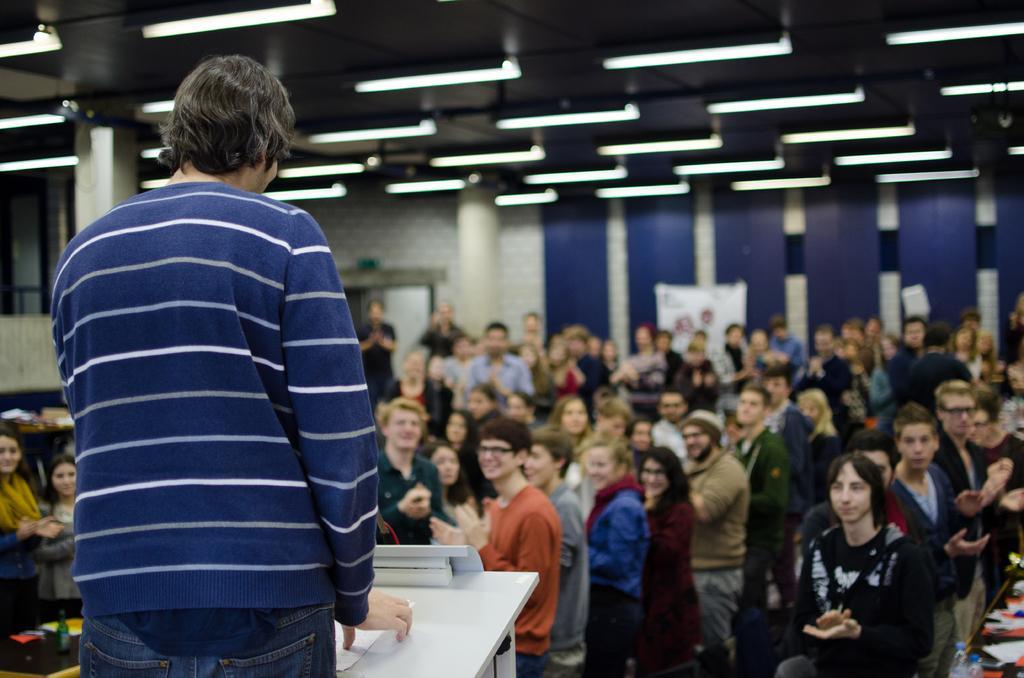Could you give a brief overview of what you see in this image? In this picture I can see a person standing in front of the table and holding paper, in front so many people are clapping their hands and also I can see some lights to the roof. 